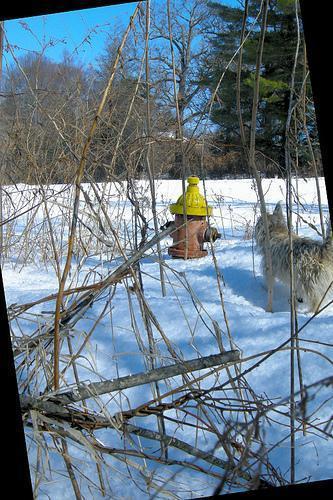How many dogs are there?
Give a very brief answer. 1. 